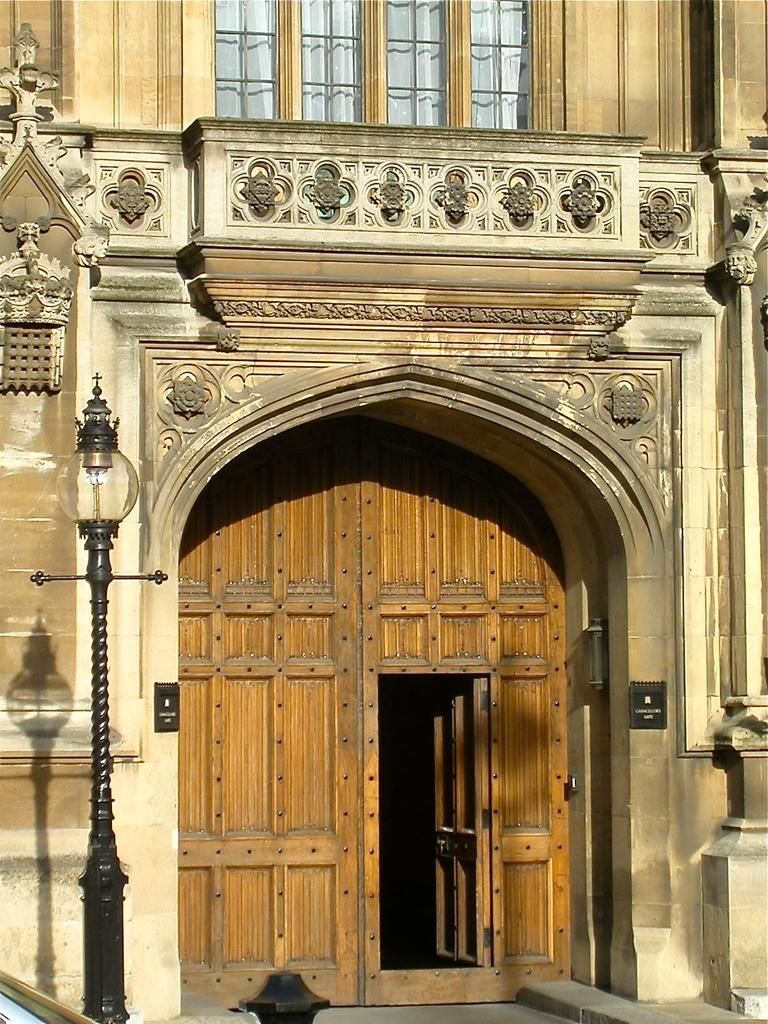What is attached to the pole on the left side of the image? There is a light attached to the pole on the left side of the image. What can be seen in the background of the image? There is a building in the background of the image. What type of gate does the building have? The building has a wooden gate. What type of window is present on the building? The building has a glass window. What angle is the nut being held at in the image? There is no nut present in the image, so it is not possible to determine the angle at which it might be held. 